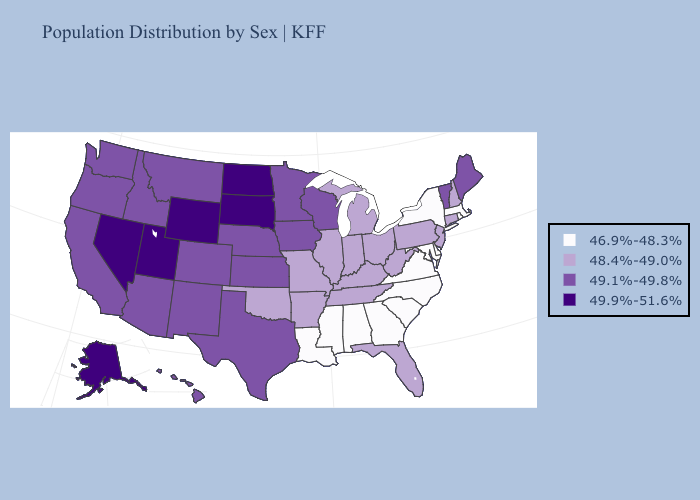Name the states that have a value in the range 46.9%-48.3%?
Concise answer only. Alabama, Delaware, Georgia, Louisiana, Maryland, Massachusetts, Mississippi, New York, North Carolina, Rhode Island, South Carolina, Virginia. Does Connecticut have the lowest value in the Northeast?
Be succinct. No. What is the highest value in states that border New Mexico?
Quick response, please. 49.9%-51.6%. Which states hav the highest value in the South?
Keep it brief. Texas. Name the states that have a value in the range 49.1%-49.8%?
Be succinct. Arizona, California, Colorado, Hawaii, Idaho, Iowa, Kansas, Maine, Minnesota, Montana, Nebraska, New Mexico, Oregon, Texas, Vermont, Washington, Wisconsin. What is the value of Illinois?
Write a very short answer. 48.4%-49.0%. What is the lowest value in the USA?
Keep it brief. 46.9%-48.3%. Does Iowa have a lower value than Alaska?
Write a very short answer. Yes. What is the highest value in states that border Virginia?
Be succinct. 48.4%-49.0%. Among the states that border Oklahoma , which have the lowest value?
Short answer required. Arkansas, Missouri. What is the lowest value in the USA?
Write a very short answer. 46.9%-48.3%. Name the states that have a value in the range 48.4%-49.0%?
Concise answer only. Arkansas, Connecticut, Florida, Illinois, Indiana, Kentucky, Michigan, Missouri, New Hampshire, New Jersey, Ohio, Oklahoma, Pennsylvania, Tennessee, West Virginia. What is the lowest value in the Northeast?
Quick response, please. 46.9%-48.3%. What is the value of Alaska?
Quick response, please. 49.9%-51.6%. Which states have the lowest value in the MidWest?
Short answer required. Illinois, Indiana, Michigan, Missouri, Ohio. 